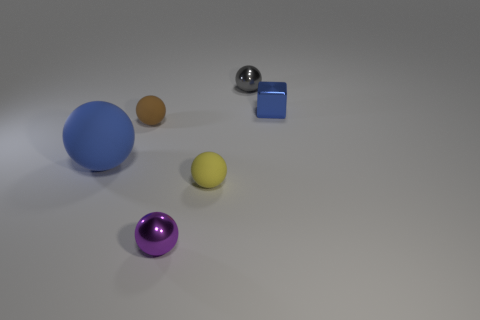Subtract all small gray shiny balls. How many balls are left? 4 Add 2 tiny metallic balls. How many objects exist? 8 Subtract all purple spheres. Subtract all cyan cylinders. How many spheres are left? 4 Subtract all brown cylinders. How many brown blocks are left? 0 Subtract all tiny green metal balls. Subtract all large blue matte spheres. How many objects are left? 5 Add 3 gray objects. How many gray objects are left? 4 Add 1 large blue rubber things. How many large blue rubber things exist? 2 Subtract all yellow spheres. How many spheres are left? 4 Subtract 0 purple cubes. How many objects are left? 6 Subtract all blocks. How many objects are left? 5 